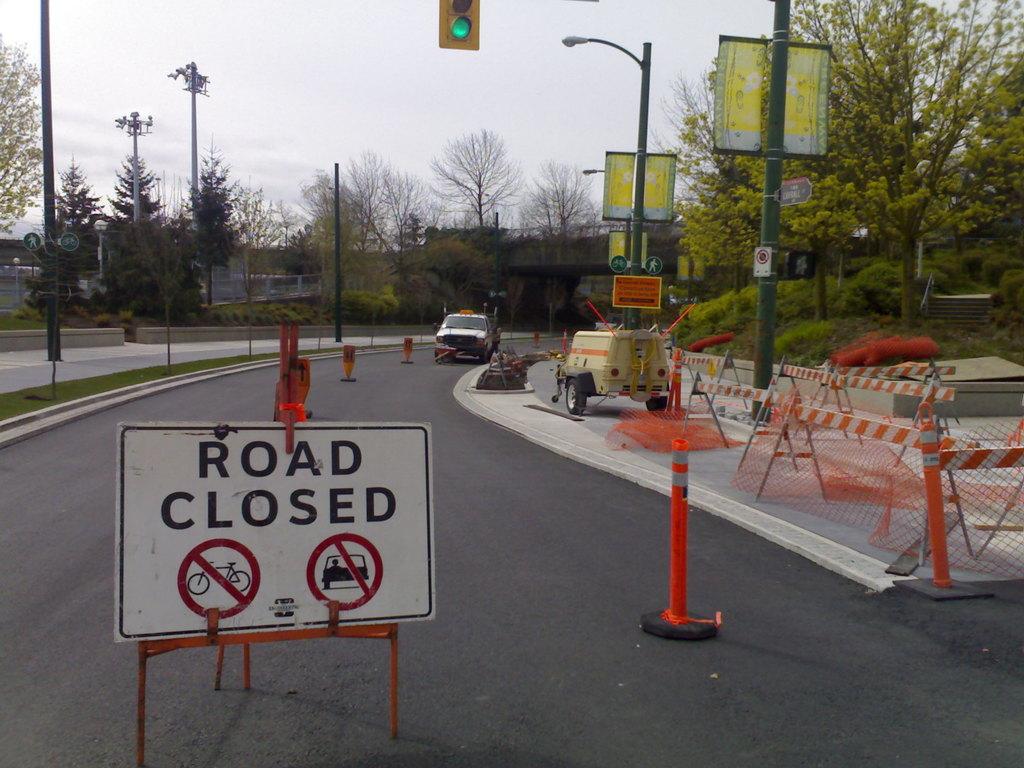What does the sign say?
Your response must be concise. Road closed. 